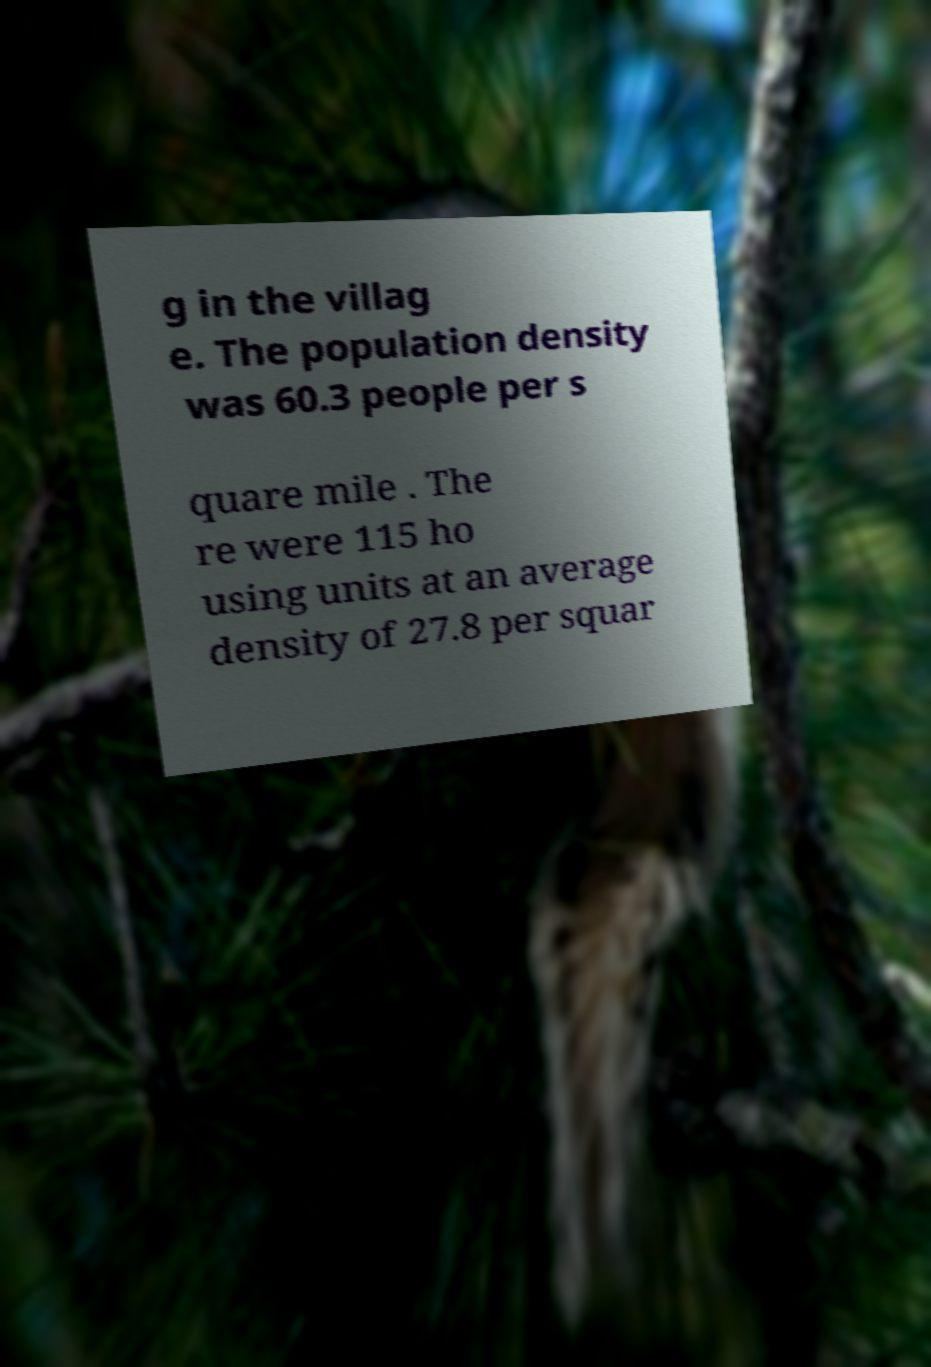Can you read and provide the text displayed in the image?This photo seems to have some interesting text. Can you extract and type it out for me? g in the villag e. The population density was 60.3 people per s quare mile . The re were 115 ho using units at an average density of 27.8 per squar 